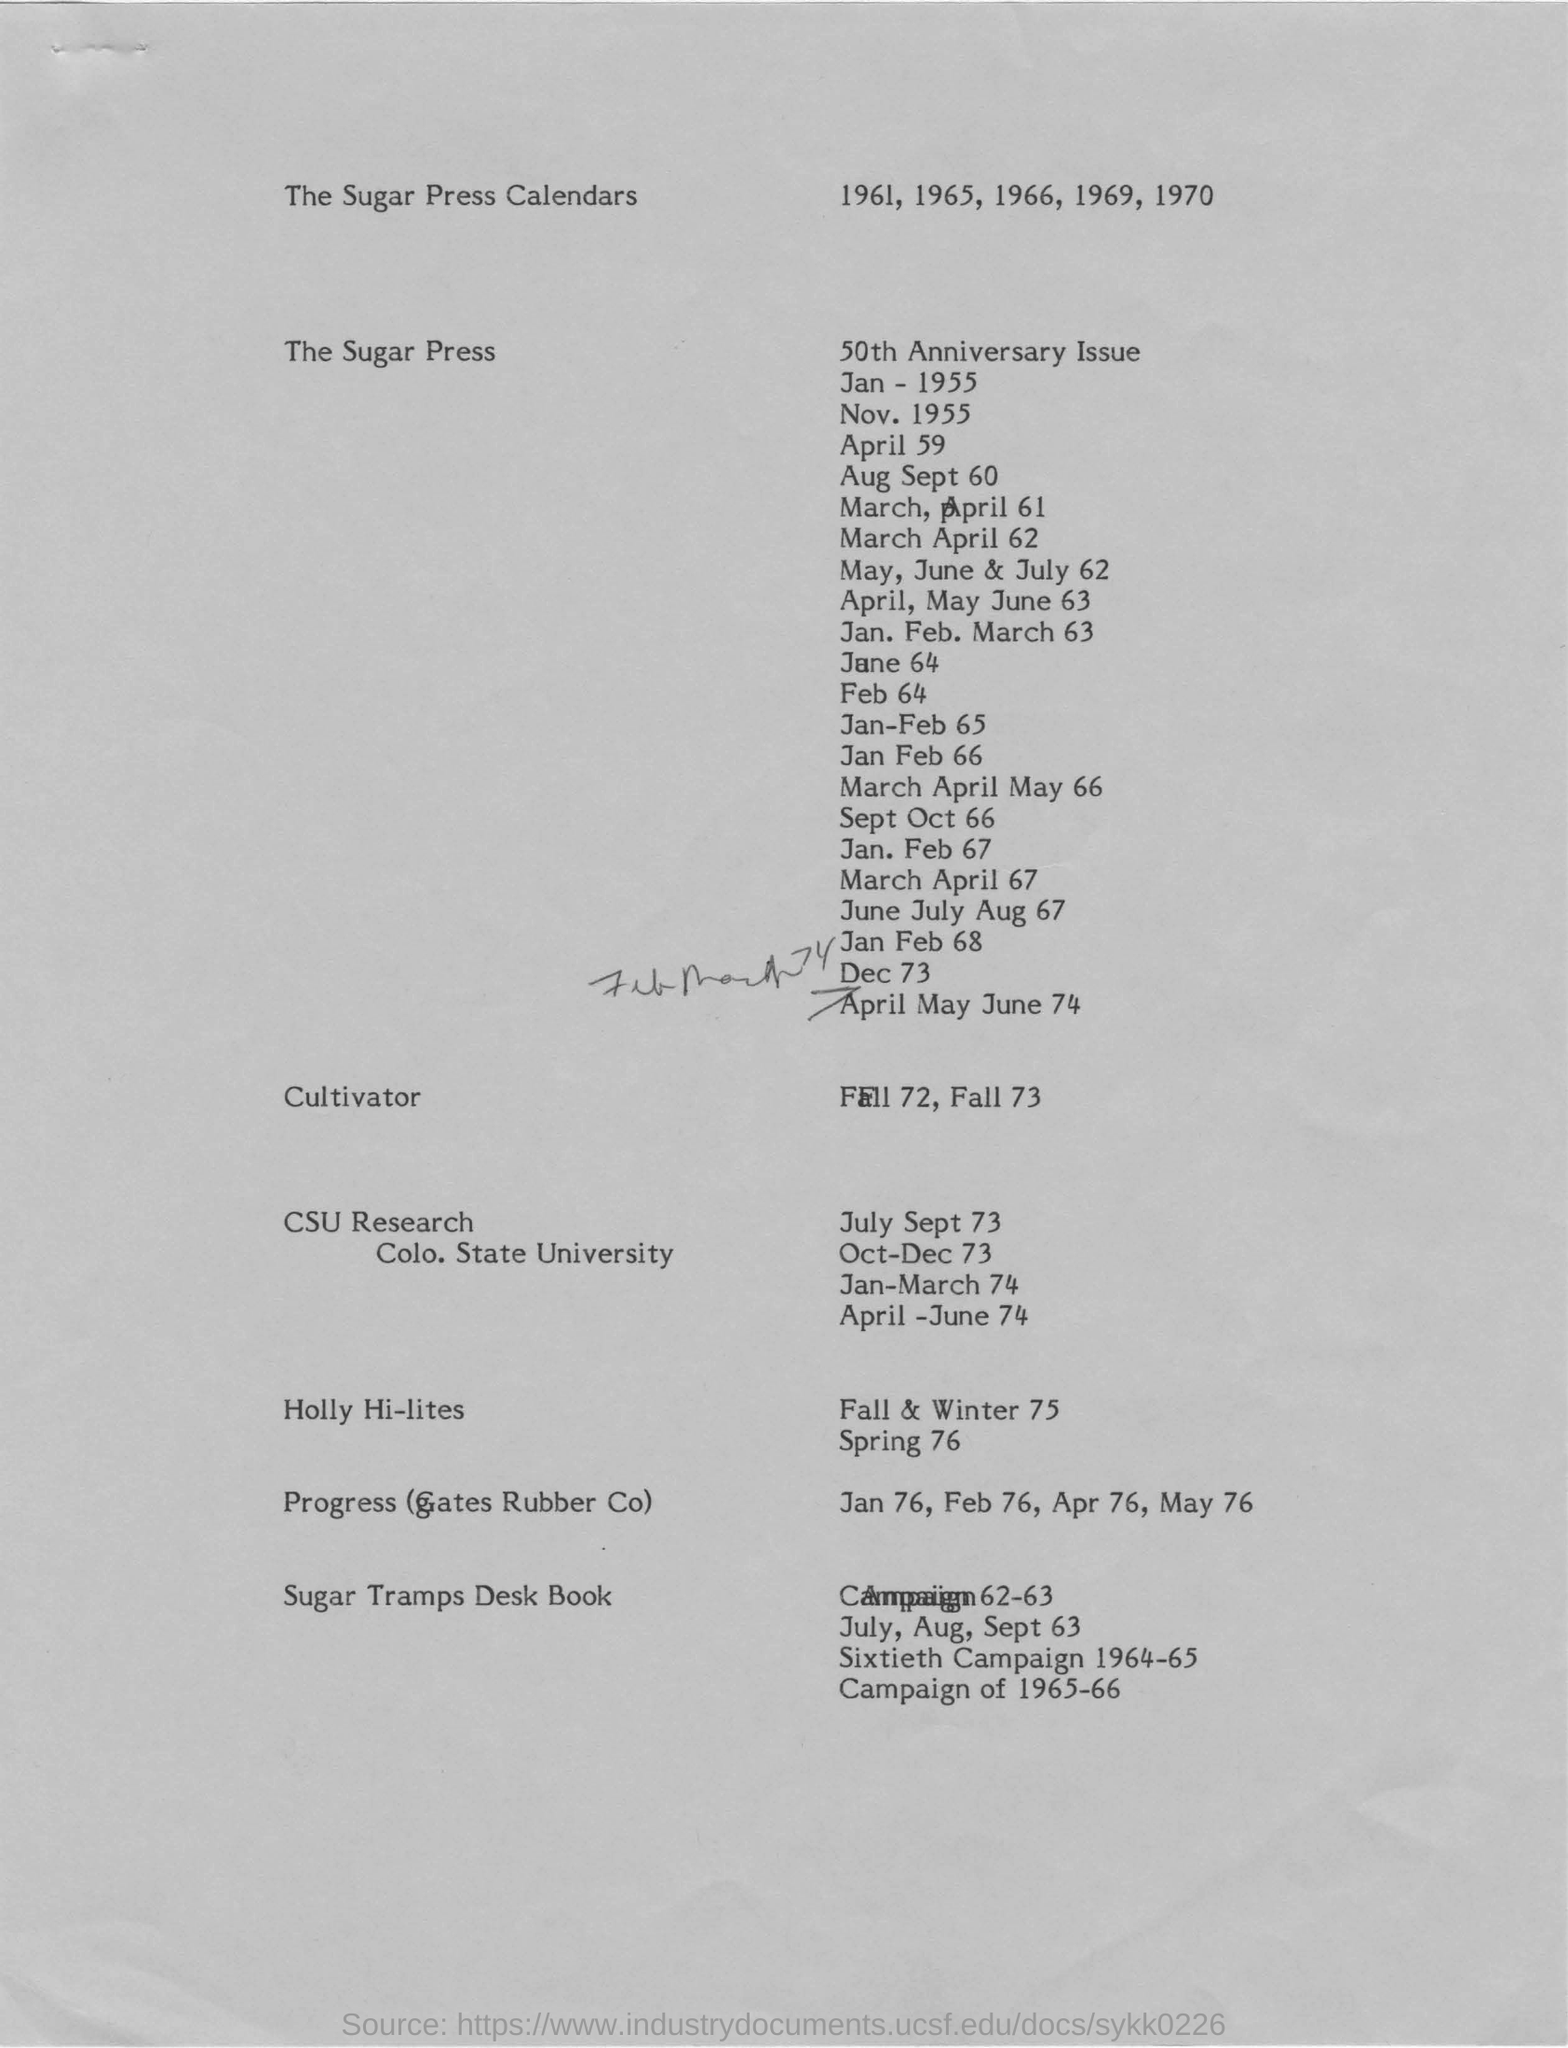Mention a couple of crucial points in this snapshot. Colorado State University is a public research university located in Fort Collins, Colorado, United States. It is commonly referred to as CSU. What is mentioned related to Fall 72 and Fall 73? Cultivator... The sugar press calendars mention the years 1961, 1965, 1966, 1969, and 1970. 